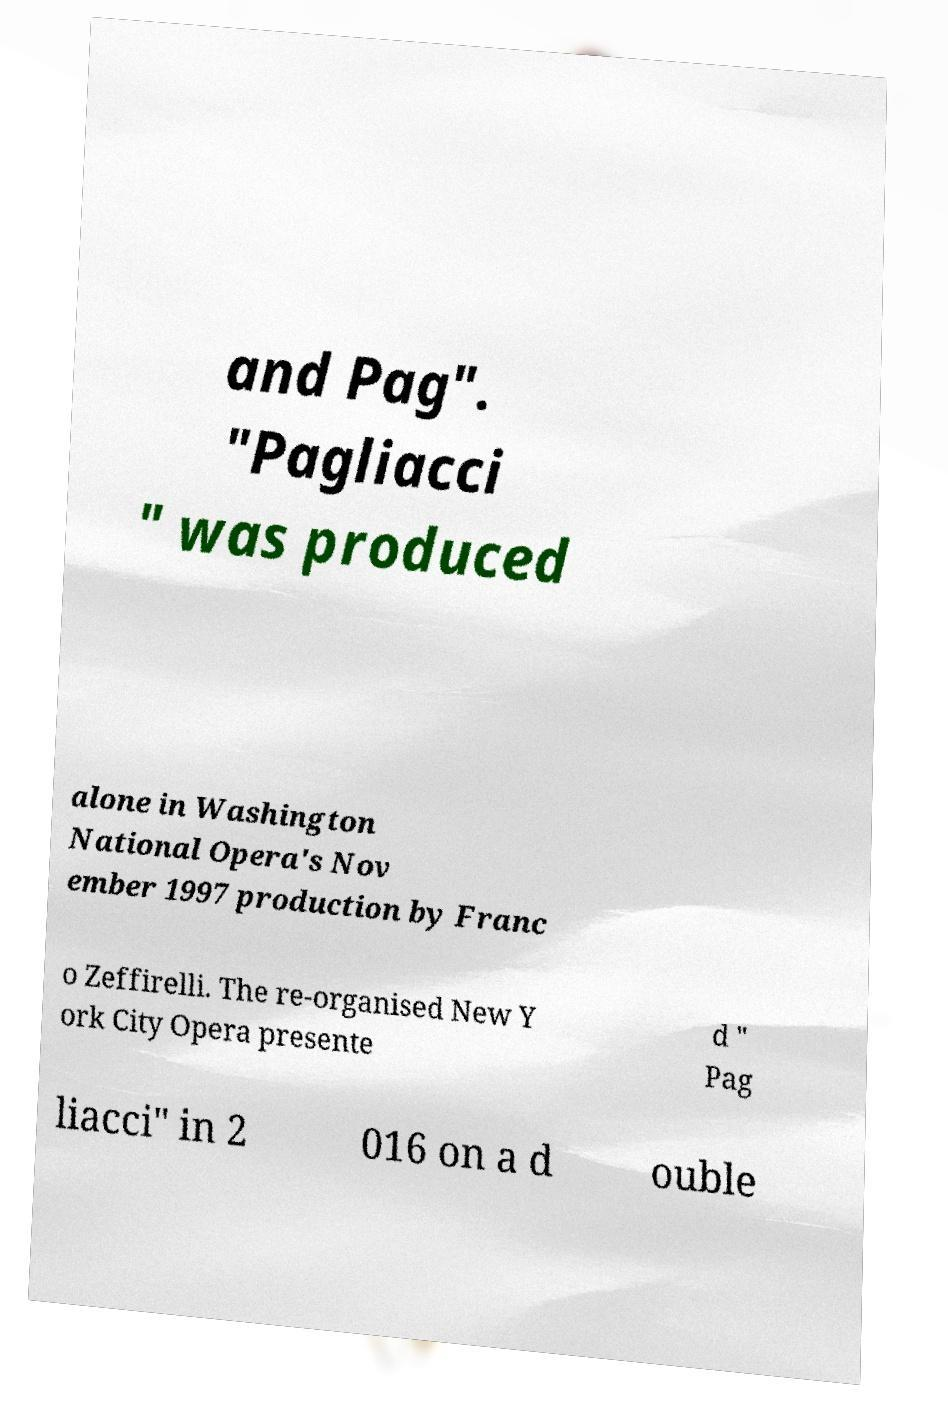Could you extract and type out the text from this image? and Pag". "Pagliacci " was produced alone in Washington National Opera's Nov ember 1997 production by Franc o Zeffirelli. The re-organised New Y ork City Opera presente d " Pag liacci" in 2 016 on a d ouble 